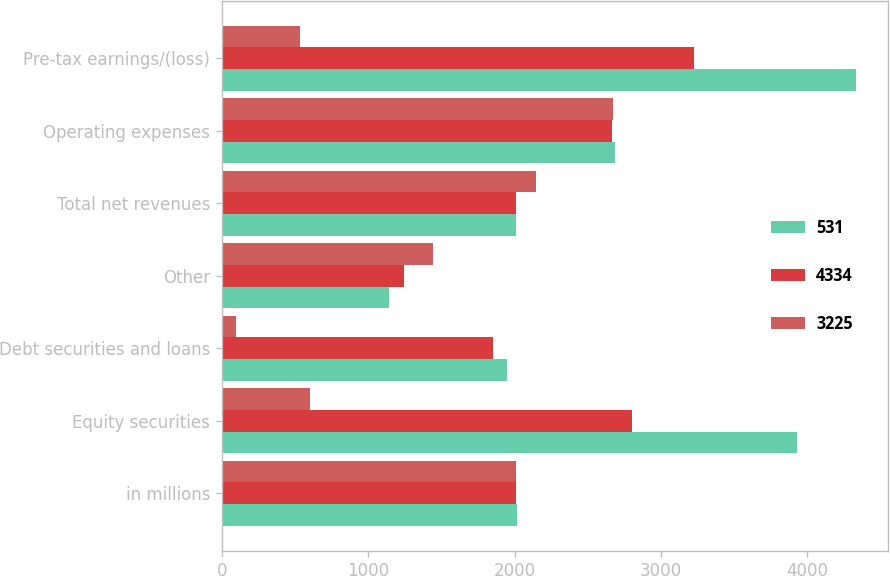<chart> <loc_0><loc_0><loc_500><loc_500><stacked_bar_chart><ecel><fcel>in millions<fcel>Equity securities<fcel>Debt securities and loans<fcel>Other<fcel>Total net revenues<fcel>Operating expenses<fcel>Pre-tax earnings/(loss)<nl><fcel>531<fcel>2013<fcel>3930<fcel>1947<fcel>1141<fcel>2012<fcel>2684<fcel>4334<nl><fcel>4334<fcel>2012<fcel>2800<fcel>1850<fcel>1241<fcel>2012<fcel>2666<fcel>3225<nl><fcel>3225<fcel>2011<fcel>603<fcel>96<fcel>1443<fcel>2142<fcel>2673<fcel>531<nl></chart> 